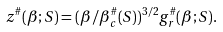Convert formula to latex. <formula><loc_0><loc_0><loc_500><loc_500>z ^ { \# } ( \beta ; S ) = ( \beta / \beta ^ { \# } _ { c } ( S ) ) ^ { 3 / 2 } g _ { r } ^ { \# } ( \beta ; S ) .</formula> 